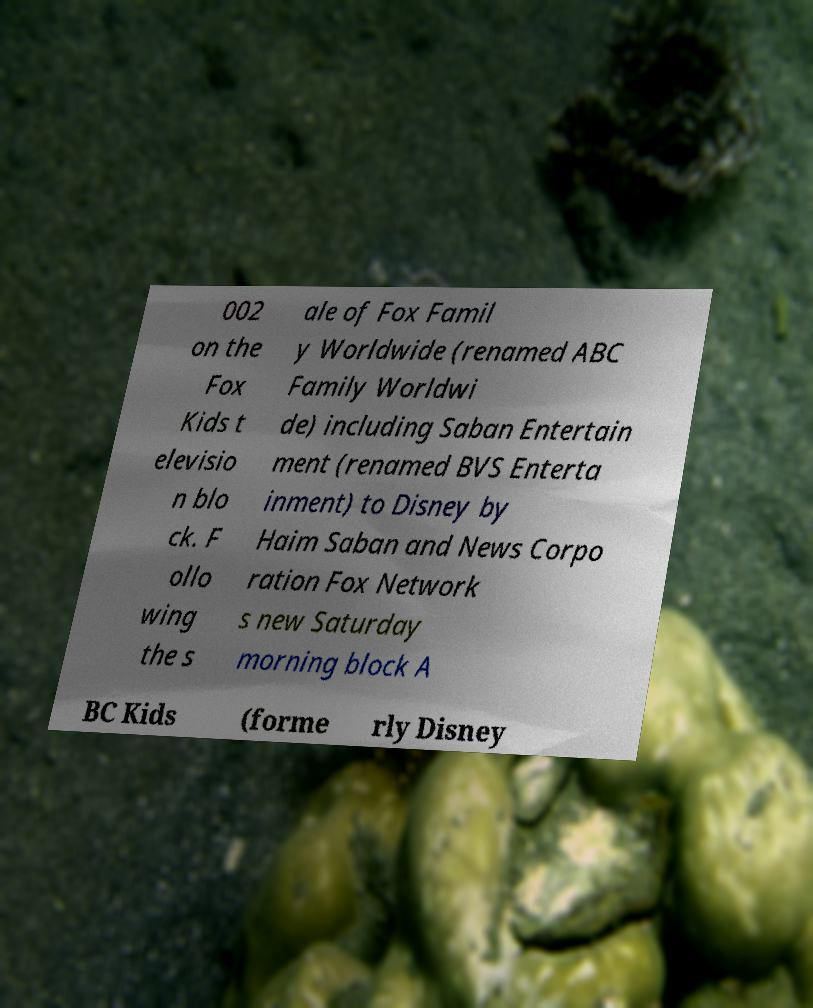Could you extract and type out the text from this image? 002 on the Fox Kids t elevisio n blo ck. F ollo wing the s ale of Fox Famil y Worldwide (renamed ABC Family Worldwi de) including Saban Entertain ment (renamed BVS Enterta inment) to Disney by Haim Saban and News Corpo ration Fox Network s new Saturday morning block A BC Kids (forme rly Disney 